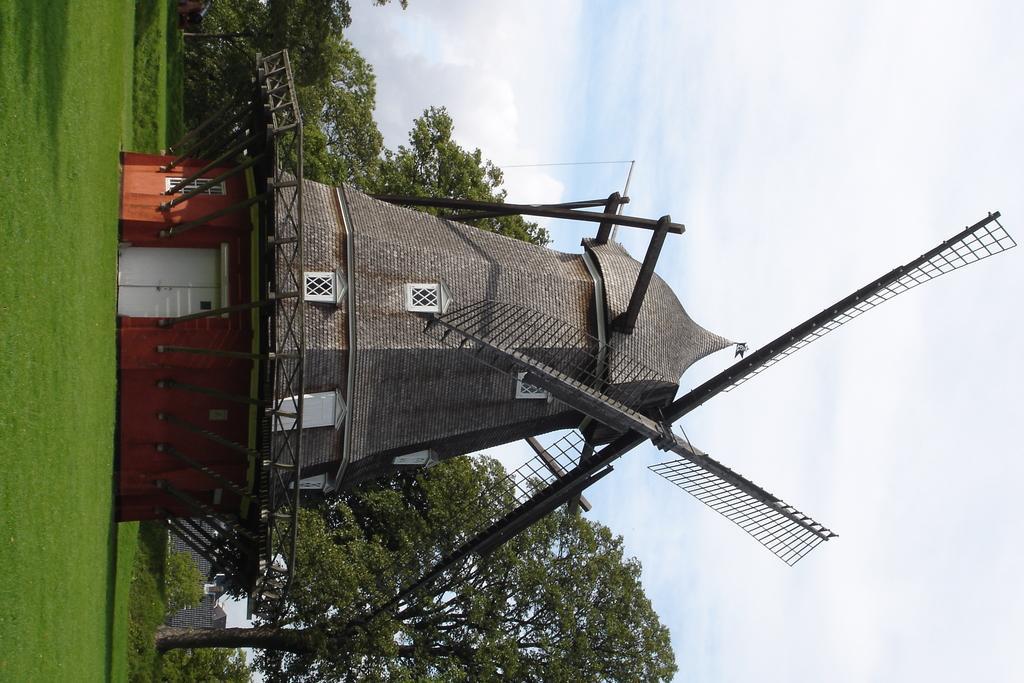How would you summarize this image in a sentence or two? In this picture I can see a windmill. In the background I can see trees, the sky and the grass. 